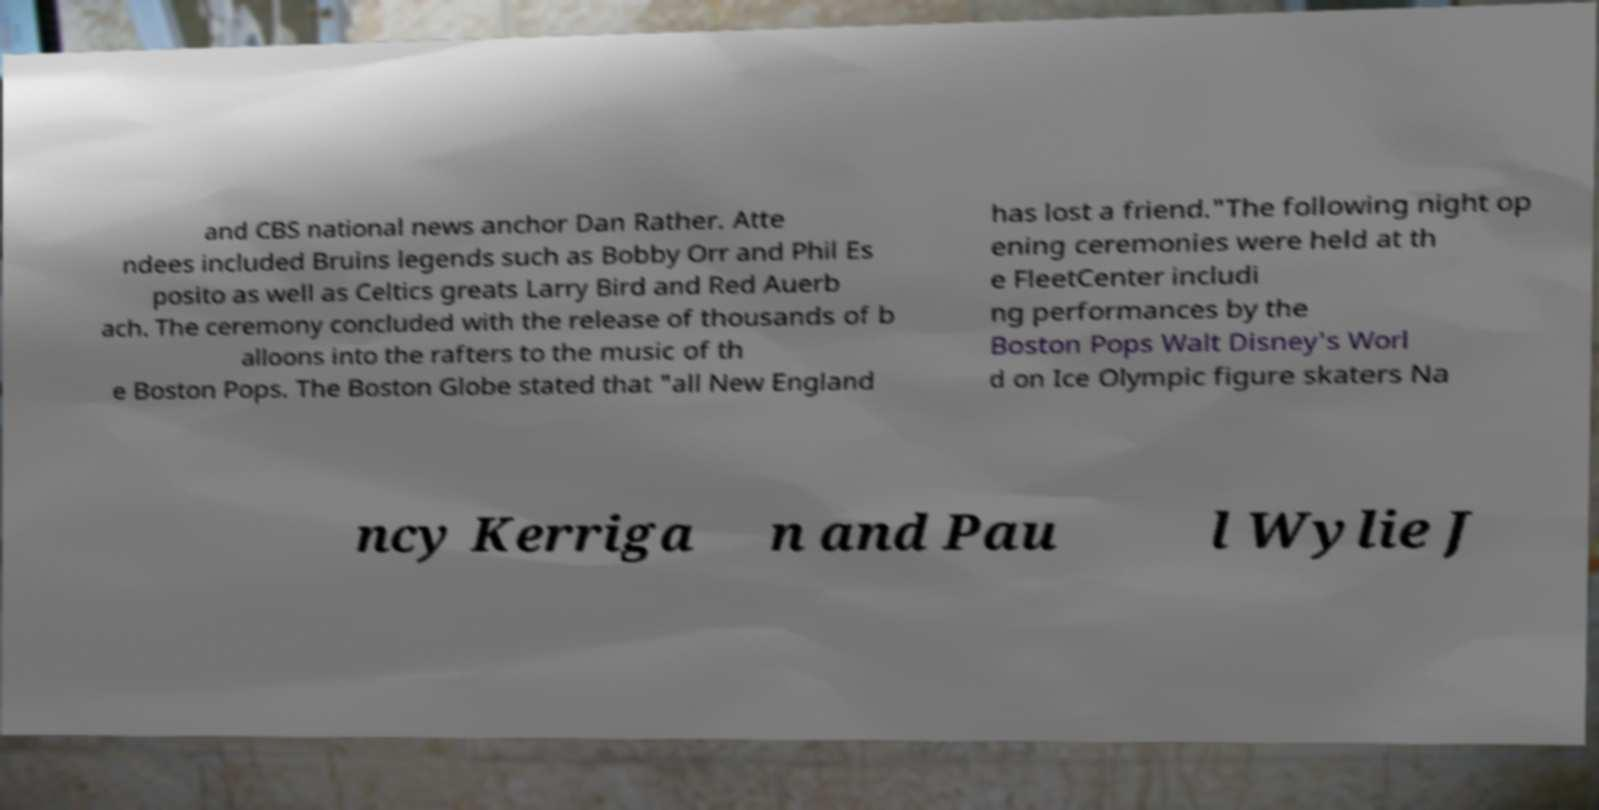Could you extract and type out the text from this image? and CBS national news anchor Dan Rather. Atte ndees included Bruins legends such as Bobby Orr and Phil Es posito as well as Celtics greats Larry Bird and Red Auerb ach. The ceremony concluded with the release of thousands of b alloons into the rafters to the music of th e Boston Pops. The Boston Globe stated that "all New England has lost a friend."The following night op ening ceremonies were held at th e FleetCenter includi ng performances by the Boston Pops Walt Disney's Worl d on Ice Olympic figure skaters Na ncy Kerriga n and Pau l Wylie J 